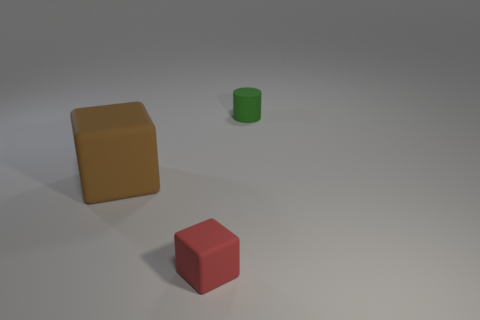What shapes are present in the image besides the blocks? Besides the blocks, there is a small green cylinder present in the image.  Does the lighting suggest anything about the time of day? The image seems to be taken in a controlled indoor environment with artificial lighting, so it doesn't suggest anything about the time of day. 